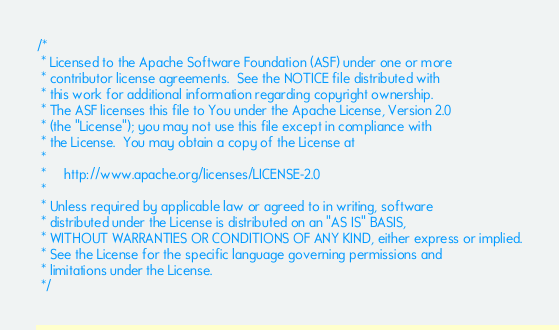Convert code to text. <code><loc_0><loc_0><loc_500><loc_500><_Java_>/*
 * Licensed to the Apache Software Foundation (ASF) under one or more
 * contributor license agreements.  See the NOTICE file distributed with
 * this work for additional information regarding copyright ownership.
 * The ASF licenses this file to You under the Apache License, Version 2.0
 * (the "License"); you may not use this file except in compliance with
 * the License.  You may obtain a copy of the License at
 *
 *     http://www.apache.org/licenses/LICENSE-2.0
 *
 * Unless required by applicable law or agreed to in writing, software
 * distributed under the License is distributed on an "AS IS" BASIS,
 * WITHOUT WARRANTIES OR CONDITIONS OF ANY KIND, either express or implied.
 * See the License for the specific language governing permissions and
 * limitations under the License.
 */
</code> 